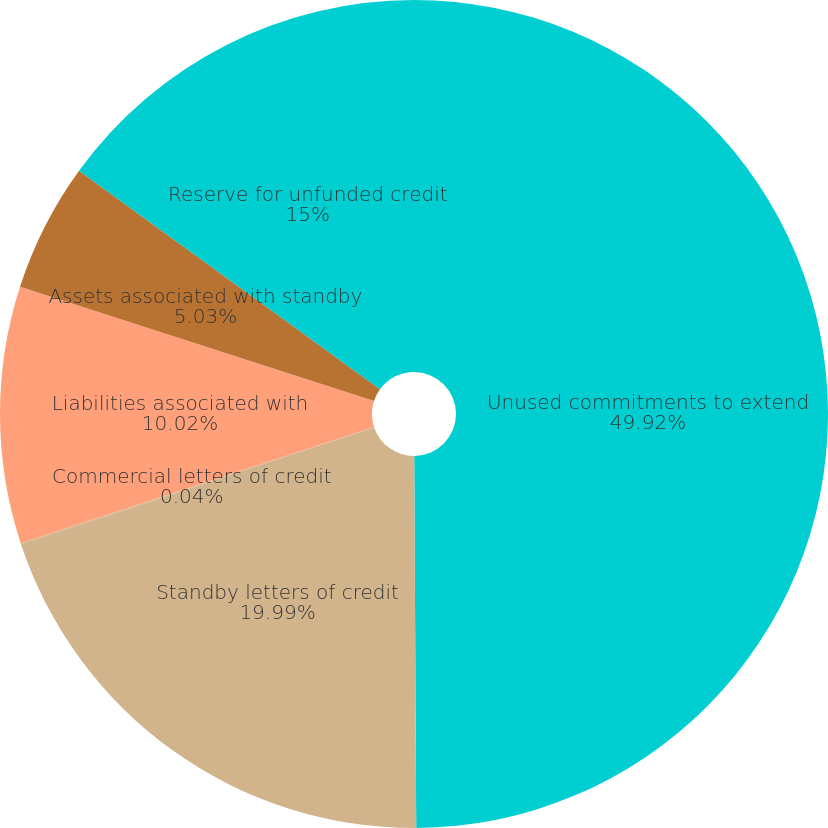Convert chart to OTSL. <chart><loc_0><loc_0><loc_500><loc_500><pie_chart><fcel>Unused commitments to extend<fcel>Standby letters of credit<fcel>Commercial letters of credit<fcel>Liabilities associated with<fcel>Assets associated with standby<fcel>Reserve for unfunded credit<nl><fcel>49.91%<fcel>19.99%<fcel>0.04%<fcel>10.02%<fcel>5.03%<fcel>15.0%<nl></chart> 